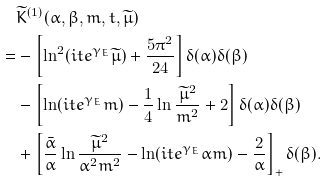<formula> <loc_0><loc_0><loc_500><loc_500>& \widetilde { K } ^ { ( 1 ) } ( \alpha , \beta , m , t , \widetilde { \mu } ) \\ = & - \left [ \ln ^ { 2 } ( i t e ^ { \gamma _ { E } } \widetilde { \mu } ) + \frac { 5 \pi ^ { 2 } } { 2 4 } \right ] \delta ( \alpha ) \delta ( \beta ) \\ & - \left [ \ln ( i t e ^ { \gamma _ { E } } m ) - \frac { 1 } { 4 } \ln \frac { \widetilde { \mu } ^ { 2 } } { m ^ { 2 } } + 2 \right ] \delta ( \alpha ) \delta ( \beta ) \\ & + \left [ \frac { \bar { \alpha } } { \alpha } \ln \frac { \widetilde { \mu } ^ { 2 } } { \alpha ^ { 2 } m ^ { 2 } } - \ln ( i t e ^ { \gamma _ { E } } \alpha m ) - \frac { 2 } { \alpha } \right ] _ { + } \delta ( \beta ) .</formula> 